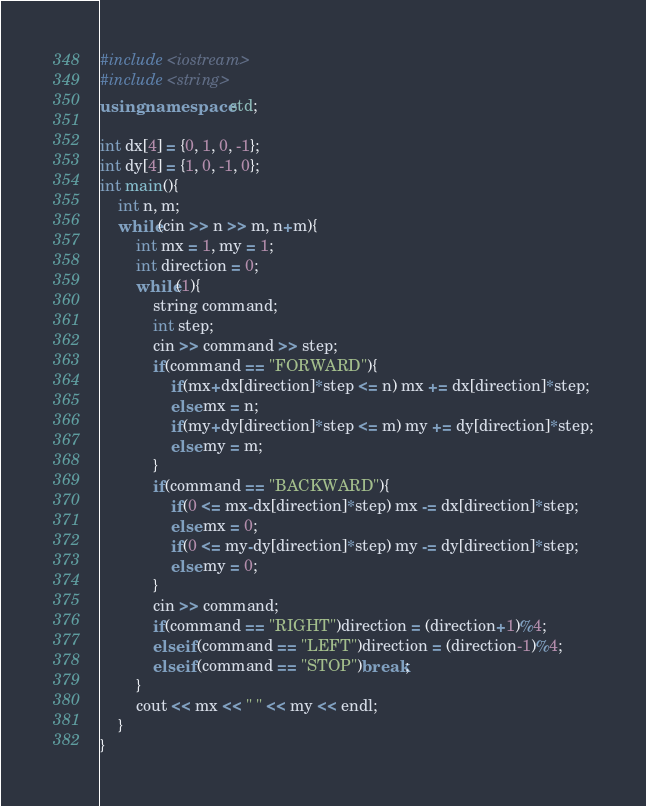Convert code to text. <code><loc_0><loc_0><loc_500><loc_500><_C++_>#include <iostream>
#include <string>
using namespace std;

int dx[4] = {0, 1, 0, -1};
int dy[4] = {1, 0, -1, 0};
int main(){
    int n, m;
    while(cin >> n >> m, n+m){
        int mx = 1, my = 1;
        int direction = 0;
        while(1){
            string command;
            int step;
            cin >> command >> step;
            if(command == "FORWARD"){
                if(mx+dx[direction]*step <= n) mx += dx[direction]*step;
                else mx = n;
                if(my+dy[direction]*step <= m) my += dy[direction]*step;
                else my = m;
            }
            if(command == "BACKWARD"){
                if(0 <= mx-dx[direction]*step) mx -= dx[direction]*step;
                else mx = 0;
                if(0 <= my-dy[direction]*step) my -= dy[direction]*step;
                else my = 0;
            }
            cin >> command;
            if(command == "RIGHT")direction = (direction+1)%4;
            else if(command == "LEFT")direction = (direction-1)%4;
            else if(command == "STOP")break;
        }
        cout << mx << " " << my << endl;
    }
}</code> 